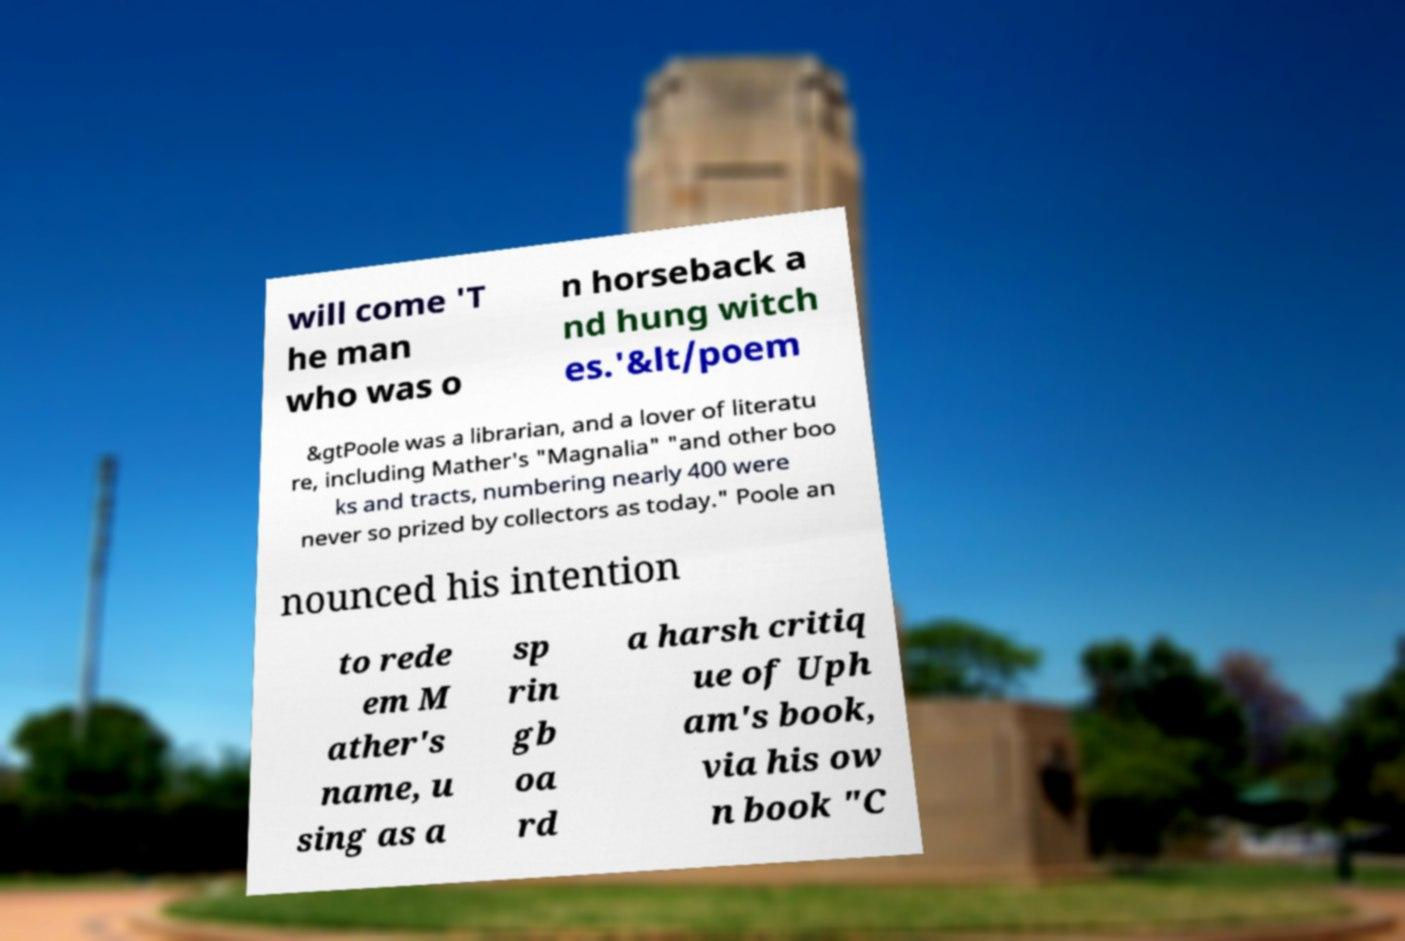Can you read and provide the text displayed in the image?This photo seems to have some interesting text. Can you extract and type it out for me? will come 'T he man who was o n horseback a nd hung witch es.'&lt/poem &gtPoole was a librarian, and a lover of literatu re, including Mather's "Magnalia" "and other boo ks and tracts, numbering nearly 400 were never so prized by collectors as today." Poole an nounced his intention to rede em M ather's name, u sing as a sp rin gb oa rd a harsh critiq ue of Uph am's book, via his ow n book "C 